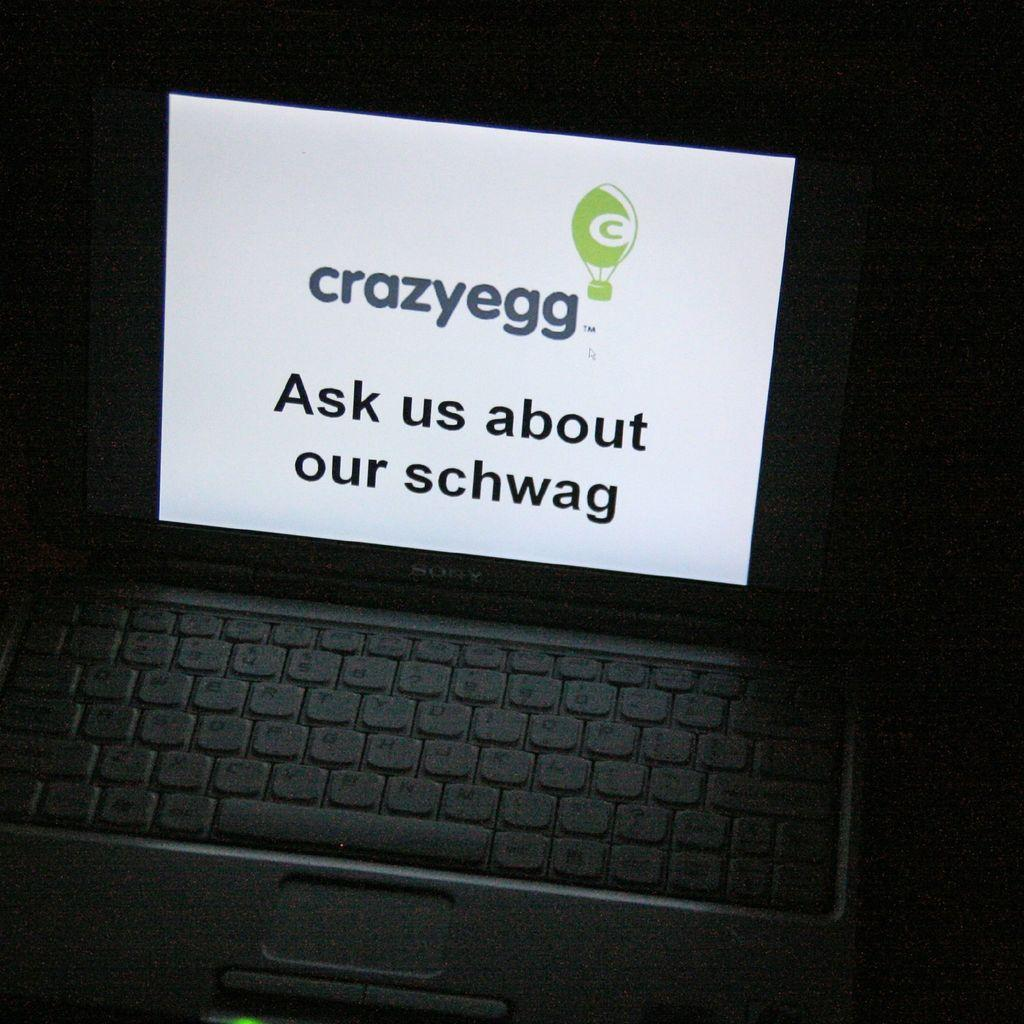<image>
Create a compact narrative representing the image presented. As shown on a laptop screen, Crazyegg wants you to ask about their schwag. 